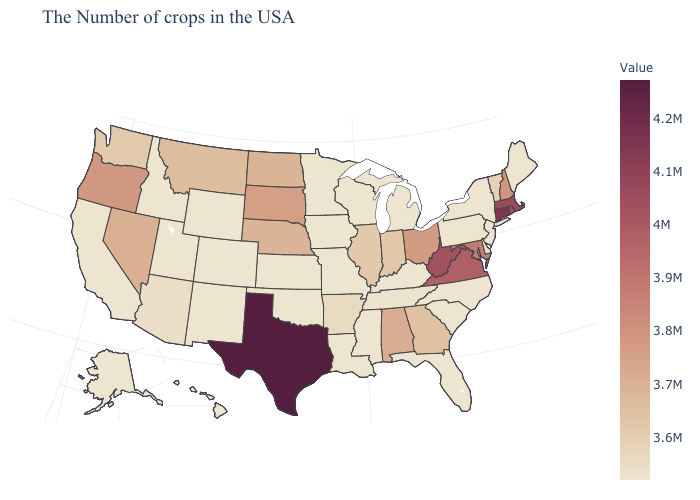Which states have the lowest value in the USA?
Write a very short answer. Maine, New York, New Jersey, Delaware, Pennsylvania, North Carolina, South Carolina, Florida, Michigan, Kentucky, Wisconsin, Mississippi, Louisiana, Missouri, Minnesota, Iowa, Kansas, Oklahoma, Wyoming, Colorado, New Mexico, Utah, Idaho, California, Alaska, Hawaii. Does North Carolina have the highest value in the USA?
Answer briefly. No. 